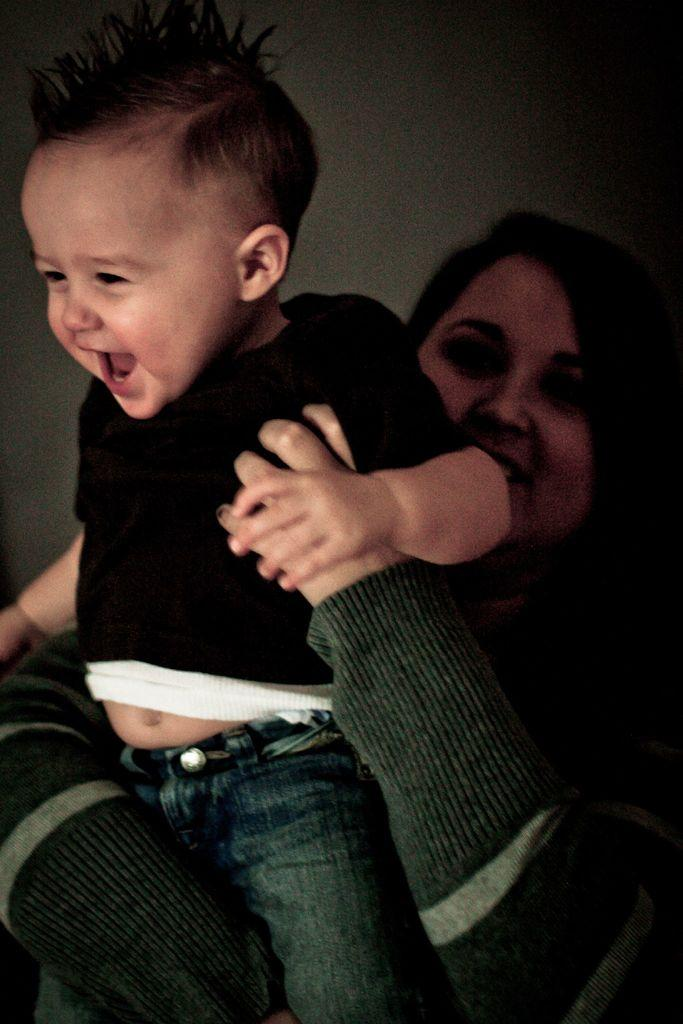Who is the main subject in the image? There is a lady in the image. What is the lady doing in the image? The lady is holding a baby. What can be seen in the background of the image? There is a wall in the background of the image. What type of waste is visible in the image? There is no waste visible in the image. How does the lady's behavior change when she is holding the baby? The image does not show any change in the lady's behavior when she is holding the baby, as it only captures a single moment in time. 